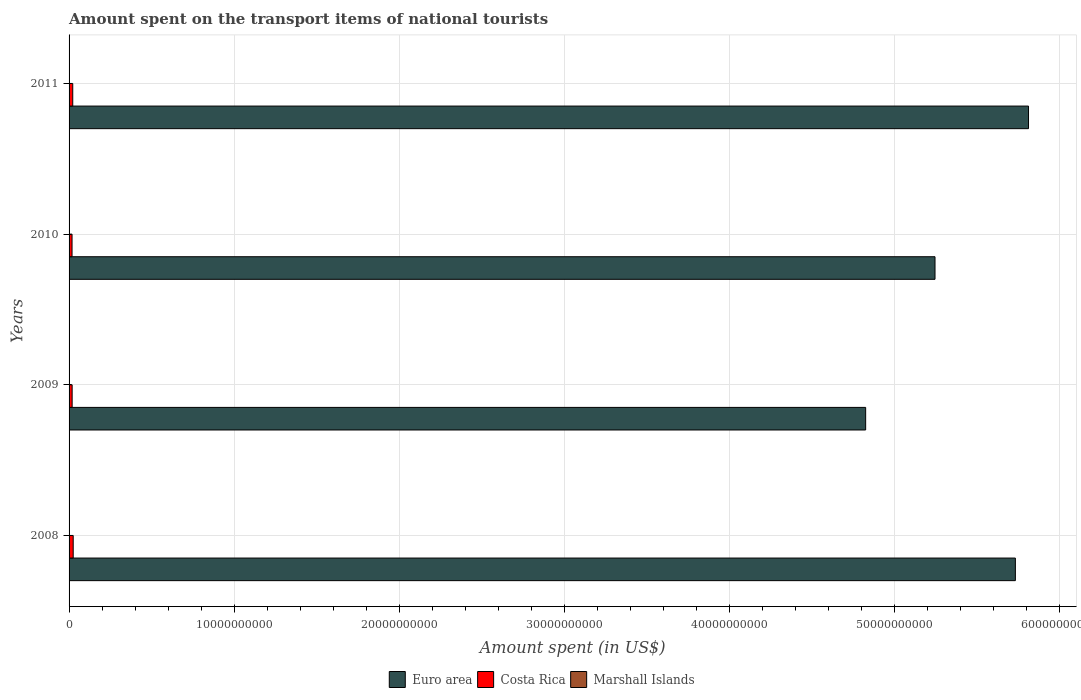How many groups of bars are there?
Offer a very short reply. 4. Are the number of bars per tick equal to the number of legend labels?
Offer a terse response. Yes. Are the number of bars on each tick of the Y-axis equal?
Offer a terse response. Yes. How many bars are there on the 4th tick from the top?
Offer a terse response. 3. In how many cases, is the number of bars for a given year not equal to the number of legend labels?
Your answer should be very brief. 0. Across all years, what is the maximum amount spent on the transport items of national tourists in Euro area?
Your answer should be very brief. 5.81e+1. Across all years, what is the minimum amount spent on the transport items of national tourists in Costa Rica?
Give a very brief answer. 1.80e+08. In which year was the amount spent on the transport items of national tourists in Marshall Islands maximum?
Offer a terse response. 2011. In which year was the amount spent on the transport items of national tourists in Costa Rica minimum?
Give a very brief answer. 2010. What is the total amount spent on the transport items of national tourists in Euro area in the graph?
Your answer should be very brief. 2.16e+11. What is the difference between the amount spent on the transport items of national tourists in Euro area in 2009 and the amount spent on the transport items of national tourists in Marshall Islands in 2008?
Offer a terse response. 4.83e+1. What is the average amount spent on the transport items of national tourists in Euro area per year?
Keep it short and to the point. 5.40e+1. In the year 2011, what is the difference between the amount spent on the transport items of national tourists in Euro area and amount spent on the transport items of national tourists in Marshall Islands?
Keep it short and to the point. 5.81e+1. What is the ratio of the amount spent on the transport items of national tourists in Marshall Islands in 2008 to that in 2010?
Your answer should be very brief. 0.44. What is the difference between the highest and the second highest amount spent on the transport items of national tourists in Costa Rica?
Your response must be concise. 2.70e+07. What is the difference between the highest and the lowest amount spent on the transport items of national tourists in Euro area?
Offer a terse response. 9.87e+09. In how many years, is the amount spent on the transport items of national tourists in Marshall Islands greater than the average amount spent on the transport items of national tourists in Marshall Islands taken over all years?
Ensure brevity in your answer.  2. Is the sum of the amount spent on the transport items of national tourists in Costa Rica in 2009 and 2011 greater than the maximum amount spent on the transport items of national tourists in Marshall Islands across all years?
Offer a terse response. Yes. What does the 2nd bar from the top in 2011 represents?
Give a very brief answer. Costa Rica. What does the 1st bar from the bottom in 2011 represents?
Offer a terse response. Euro area. Is it the case that in every year, the sum of the amount spent on the transport items of national tourists in Euro area and amount spent on the transport items of national tourists in Marshall Islands is greater than the amount spent on the transport items of national tourists in Costa Rica?
Offer a very short reply. Yes. How many bars are there?
Provide a short and direct response. 12. Are all the bars in the graph horizontal?
Keep it short and to the point. Yes. How many years are there in the graph?
Your answer should be compact. 4. Are the values on the major ticks of X-axis written in scientific E-notation?
Ensure brevity in your answer.  No. How many legend labels are there?
Provide a short and direct response. 3. What is the title of the graph?
Keep it short and to the point. Amount spent on the transport items of national tourists. What is the label or title of the X-axis?
Your answer should be very brief. Amount spent (in US$). What is the label or title of the Y-axis?
Provide a succinct answer. Years. What is the Amount spent (in US$) in Euro area in 2008?
Provide a short and direct response. 5.73e+1. What is the Amount spent (in US$) in Costa Rica in 2008?
Provide a succinct answer. 2.50e+08. What is the Amount spent (in US$) of Euro area in 2009?
Give a very brief answer. 4.83e+1. What is the Amount spent (in US$) of Costa Rica in 2009?
Provide a succinct answer. 1.86e+08. What is the Amount spent (in US$) in Marshall Islands in 2009?
Offer a very short reply. 1.80e+05. What is the Amount spent (in US$) in Euro area in 2010?
Provide a short and direct response. 5.25e+1. What is the Amount spent (in US$) of Costa Rica in 2010?
Give a very brief answer. 1.80e+08. What is the Amount spent (in US$) of Euro area in 2011?
Ensure brevity in your answer.  5.81e+1. What is the Amount spent (in US$) of Costa Rica in 2011?
Your answer should be compact. 2.23e+08. Across all years, what is the maximum Amount spent (in US$) of Euro area?
Offer a terse response. 5.81e+1. Across all years, what is the maximum Amount spent (in US$) of Costa Rica?
Give a very brief answer. 2.50e+08. Across all years, what is the minimum Amount spent (in US$) of Euro area?
Offer a very short reply. 4.83e+1. Across all years, what is the minimum Amount spent (in US$) of Costa Rica?
Your answer should be compact. 1.80e+08. What is the total Amount spent (in US$) in Euro area in the graph?
Ensure brevity in your answer.  2.16e+11. What is the total Amount spent (in US$) of Costa Rica in the graph?
Keep it short and to the point. 8.39e+08. What is the total Amount spent (in US$) of Marshall Islands in the graph?
Provide a succinct answer. 8.20e+05. What is the difference between the Amount spent (in US$) of Euro area in 2008 and that in 2009?
Your response must be concise. 9.07e+09. What is the difference between the Amount spent (in US$) of Costa Rica in 2008 and that in 2009?
Offer a terse response. 6.40e+07. What is the difference between the Amount spent (in US$) of Euro area in 2008 and that in 2010?
Make the answer very short. 4.87e+09. What is the difference between the Amount spent (in US$) of Costa Rica in 2008 and that in 2010?
Ensure brevity in your answer.  7.00e+07. What is the difference between the Amount spent (in US$) in Marshall Islands in 2008 and that in 2010?
Offer a very short reply. -1.40e+05. What is the difference between the Amount spent (in US$) of Euro area in 2008 and that in 2011?
Your answer should be compact. -7.97e+08. What is the difference between the Amount spent (in US$) in Costa Rica in 2008 and that in 2011?
Your answer should be very brief. 2.70e+07. What is the difference between the Amount spent (in US$) in Euro area in 2009 and that in 2010?
Provide a succinct answer. -4.20e+09. What is the difference between the Amount spent (in US$) in Euro area in 2009 and that in 2011?
Your answer should be compact. -9.87e+09. What is the difference between the Amount spent (in US$) of Costa Rica in 2009 and that in 2011?
Your response must be concise. -3.70e+07. What is the difference between the Amount spent (in US$) of Marshall Islands in 2009 and that in 2011?
Give a very brief answer. -1.00e+05. What is the difference between the Amount spent (in US$) in Euro area in 2010 and that in 2011?
Your answer should be very brief. -5.66e+09. What is the difference between the Amount spent (in US$) in Costa Rica in 2010 and that in 2011?
Your response must be concise. -4.30e+07. What is the difference between the Amount spent (in US$) of Euro area in 2008 and the Amount spent (in US$) of Costa Rica in 2009?
Make the answer very short. 5.71e+1. What is the difference between the Amount spent (in US$) of Euro area in 2008 and the Amount spent (in US$) of Marshall Islands in 2009?
Keep it short and to the point. 5.73e+1. What is the difference between the Amount spent (in US$) of Costa Rica in 2008 and the Amount spent (in US$) of Marshall Islands in 2009?
Ensure brevity in your answer.  2.50e+08. What is the difference between the Amount spent (in US$) in Euro area in 2008 and the Amount spent (in US$) in Costa Rica in 2010?
Your answer should be very brief. 5.71e+1. What is the difference between the Amount spent (in US$) in Euro area in 2008 and the Amount spent (in US$) in Marshall Islands in 2010?
Offer a very short reply. 5.73e+1. What is the difference between the Amount spent (in US$) of Costa Rica in 2008 and the Amount spent (in US$) of Marshall Islands in 2010?
Make the answer very short. 2.50e+08. What is the difference between the Amount spent (in US$) of Euro area in 2008 and the Amount spent (in US$) of Costa Rica in 2011?
Offer a very short reply. 5.71e+1. What is the difference between the Amount spent (in US$) of Euro area in 2008 and the Amount spent (in US$) of Marshall Islands in 2011?
Give a very brief answer. 5.73e+1. What is the difference between the Amount spent (in US$) in Costa Rica in 2008 and the Amount spent (in US$) in Marshall Islands in 2011?
Give a very brief answer. 2.50e+08. What is the difference between the Amount spent (in US$) of Euro area in 2009 and the Amount spent (in US$) of Costa Rica in 2010?
Your response must be concise. 4.81e+1. What is the difference between the Amount spent (in US$) in Euro area in 2009 and the Amount spent (in US$) in Marshall Islands in 2010?
Give a very brief answer. 4.83e+1. What is the difference between the Amount spent (in US$) of Costa Rica in 2009 and the Amount spent (in US$) of Marshall Islands in 2010?
Provide a succinct answer. 1.86e+08. What is the difference between the Amount spent (in US$) of Euro area in 2009 and the Amount spent (in US$) of Costa Rica in 2011?
Provide a short and direct response. 4.80e+1. What is the difference between the Amount spent (in US$) of Euro area in 2009 and the Amount spent (in US$) of Marshall Islands in 2011?
Ensure brevity in your answer.  4.83e+1. What is the difference between the Amount spent (in US$) in Costa Rica in 2009 and the Amount spent (in US$) in Marshall Islands in 2011?
Make the answer very short. 1.86e+08. What is the difference between the Amount spent (in US$) of Euro area in 2010 and the Amount spent (in US$) of Costa Rica in 2011?
Offer a very short reply. 5.22e+1. What is the difference between the Amount spent (in US$) in Euro area in 2010 and the Amount spent (in US$) in Marshall Islands in 2011?
Provide a short and direct response. 5.25e+1. What is the difference between the Amount spent (in US$) in Costa Rica in 2010 and the Amount spent (in US$) in Marshall Islands in 2011?
Provide a short and direct response. 1.80e+08. What is the average Amount spent (in US$) in Euro area per year?
Your response must be concise. 5.40e+1. What is the average Amount spent (in US$) of Costa Rica per year?
Provide a succinct answer. 2.10e+08. What is the average Amount spent (in US$) of Marshall Islands per year?
Offer a terse response. 2.05e+05. In the year 2008, what is the difference between the Amount spent (in US$) of Euro area and Amount spent (in US$) of Costa Rica?
Keep it short and to the point. 5.71e+1. In the year 2008, what is the difference between the Amount spent (in US$) in Euro area and Amount spent (in US$) in Marshall Islands?
Provide a succinct answer. 5.73e+1. In the year 2008, what is the difference between the Amount spent (in US$) in Costa Rica and Amount spent (in US$) in Marshall Islands?
Your answer should be very brief. 2.50e+08. In the year 2009, what is the difference between the Amount spent (in US$) in Euro area and Amount spent (in US$) in Costa Rica?
Offer a very short reply. 4.81e+1. In the year 2009, what is the difference between the Amount spent (in US$) in Euro area and Amount spent (in US$) in Marshall Islands?
Keep it short and to the point. 4.83e+1. In the year 2009, what is the difference between the Amount spent (in US$) in Costa Rica and Amount spent (in US$) in Marshall Islands?
Offer a very short reply. 1.86e+08. In the year 2010, what is the difference between the Amount spent (in US$) in Euro area and Amount spent (in US$) in Costa Rica?
Your response must be concise. 5.23e+1. In the year 2010, what is the difference between the Amount spent (in US$) of Euro area and Amount spent (in US$) of Marshall Islands?
Provide a short and direct response. 5.25e+1. In the year 2010, what is the difference between the Amount spent (in US$) of Costa Rica and Amount spent (in US$) of Marshall Islands?
Provide a succinct answer. 1.80e+08. In the year 2011, what is the difference between the Amount spent (in US$) in Euro area and Amount spent (in US$) in Costa Rica?
Provide a short and direct response. 5.79e+1. In the year 2011, what is the difference between the Amount spent (in US$) in Euro area and Amount spent (in US$) in Marshall Islands?
Your response must be concise. 5.81e+1. In the year 2011, what is the difference between the Amount spent (in US$) of Costa Rica and Amount spent (in US$) of Marshall Islands?
Provide a short and direct response. 2.23e+08. What is the ratio of the Amount spent (in US$) of Euro area in 2008 to that in 2009?
Provide a succinct answer. 1.19. What is the ratio of the Amount spent (in US$) in Costa Rica in 2008 to that in 2009?
Keep it short and to the point. 1.34. What is the ratio of the Amount spent (in US$) of Marshall Islands in 2008 to that in 2009?
Your answer should be very brief. 0.61. What is the ratio of the Amount spent (in US$) of Euro area in 2008 to that in 2010?
Your response must be concise. 1.09. What is the ratio of the Amount spent (in US$) in Costa Rica in 2008 to that in 2010?
Your answer should be compact. 1.39. What is the ratio of the Amount spent (in US$) of Marshall Islands in 2008 to that in 2010?
Your answer should be very brief. 0.44. What is the ratio of the Amount spent (in US$) of Euro area in 2008 to that in 2011?
Provide a succinct answer. 0.99. What is the ratio of the Amount spent (in US$) of Costa Rica in 2008 to that in 2011?
Provide a short and direct response. 1.12. What is the ratio of the Amount spent (in US$) of Marshall Islands in 2008 to that in 2011?
Your answer should be compact. 0.39. What is the ratio of the Amount spent (in US$) in Euro area in 2009 to that in 2010?
Keep it short and to the point. 0.92. What is the ratio of the Amount spent (in US$) in Costa Rica in 2009 to that in 2010?
Provide a succinct answer. 1.03. What is the ratio of the Amount spent (in US$) of Marshall Islands in 2009 to that in 2010?
Your answer should be compact. 0.72. What is the ratio of the Amount spent (in US$) in Euro area in 2009 to that in 2011?
Your answer should be compact. 0.83. What is the ratio of the Amount spent (in US$) of Costa Rica in 2009 to that in 2011?
Provide a succinct answer. 0.83. What is the ratio of the Amount spent (in US$) in Marshall Islands in 2009 to that in 2011?
Offer a terse response. 0.64. What is the ratio of the Amount spent (in US$) in Euro area in 2010 to that in 2011?
Keep it short and to the point. 0.9. What is the ratio of the Amount spent (in US$) of Costa Rica in 2010 to that in 2011?
Keep it short and to the point. 0.81. What is the ratio of the Amount spent (in US$) of Marshall Islands in 2010 to that in 2011?
Provide a short and direct response. 0.89. What is the difference between the highest and the second highest Amount spent (in US$) in Euro area?
Your answer should be very brief. 7.97e+08. What is the difference between the highest and the second highest Amount spent (in US$) in Costa Rica?
Make the answer very short. 2.70e+07. What is the difference between the highest and the lowest Amount spent (in US$) of Euro area?
Keep it short and to the point. 9.87e+09. What is the difference between the highest and the lowest Amount spent (in US$) in Costa Rica?
Your answer should be compact. 7.00e+07. 